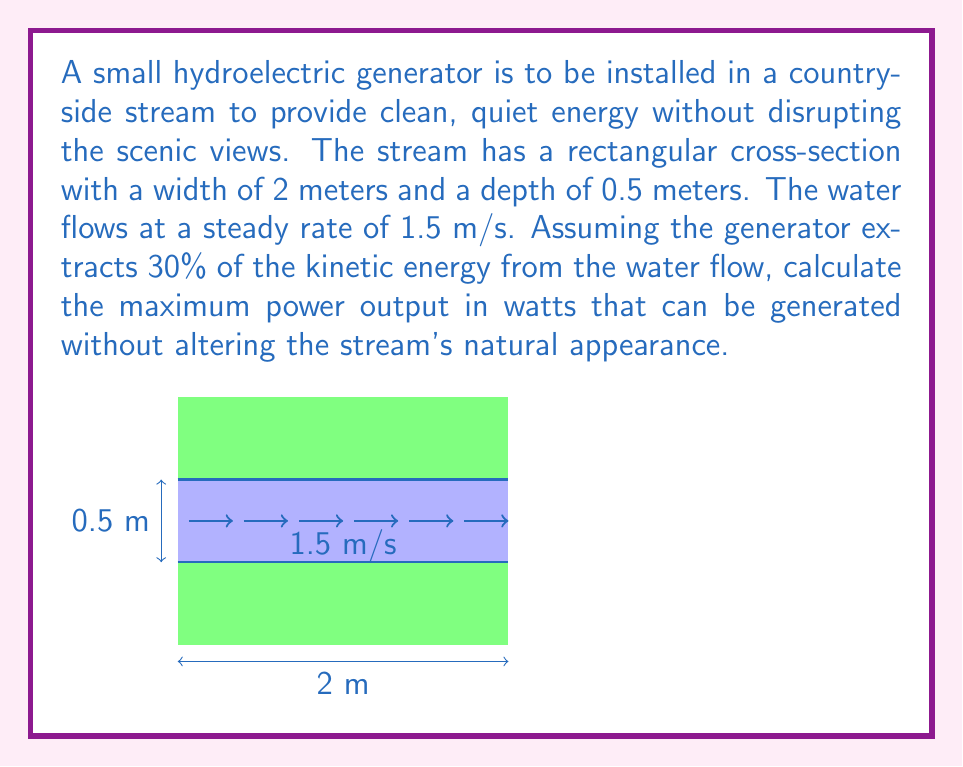Could you help me with this problem? To solve this problem, we'll follow these steps:

1) First, we need to calculate the cross-sectional area of the stream:
   $A = width \times depth = 2 \text{ m} \times 0.5 \text{ m} = 1 \text{ m}^2$

2) Next, we calculate the volume flow rate:
   $Q = A \times v = 1 \text{ m}^2 \times 1.5 \text{ m/s} = 1.5 \text{ m}^3/s$

3) The kinetic energy per unit time (power) of the flowing water is given by:
   $P = \frac{1}{2} \rho Q v^2$
   where $\rho$ is the density of water (1000 kg/m³)

4) Substituting the values:
   $P = \frac{1}{2} \times 1000 \text{ kg/m}^3 \times 1.5 \text{ m}^3/s \times (1.5 \text{ m/s})^2$
   $P = 1687.5 \text{ W}$

5) The generator extracts 30% of this energy, so the maximum power output is:
   $P_{output} = 0.30 \times 1687.5 \text{ W} = 506.25 \text{ W}$
Answer: 506.25 W 